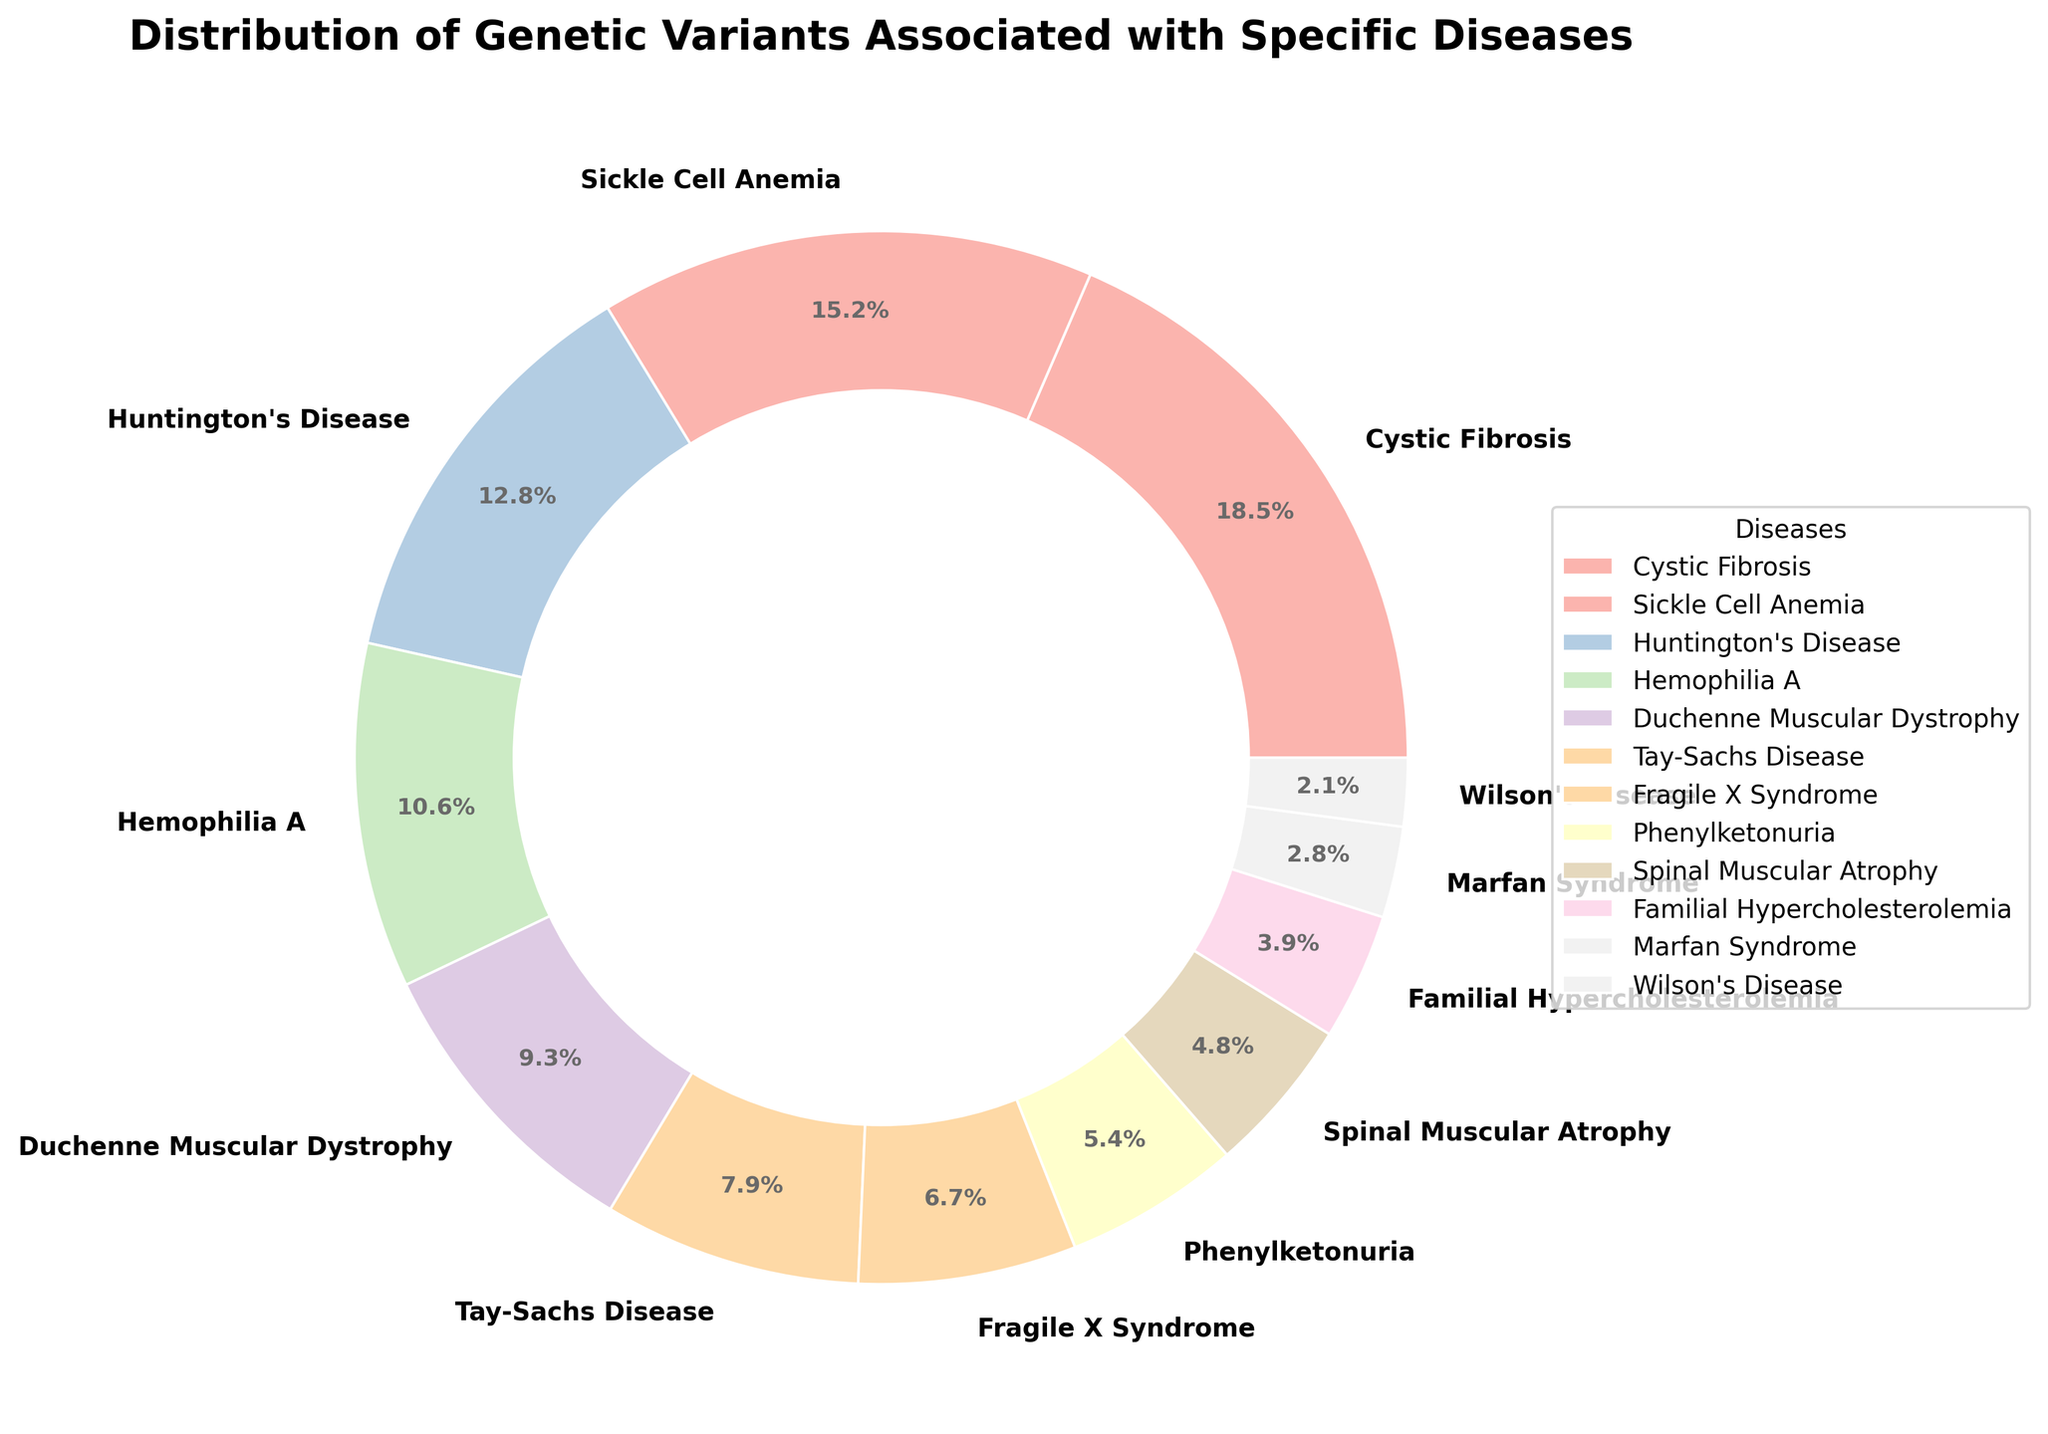What disease has the highest percentage of genetic variants? To determine the disease with the highest percentage of genetic variants, we look at the pie chart and identify the largest wedge. Cystic Fibrosis has the largest slice with 18.5%.
Answer: Cystic Fibrosis Which disease contributes the least to the distribution of genetic variants? We identify the smallest wedge in the pie chart to find the disease contributing the least. Wilson's Disease has the smallest slice with 2.1%.
Answer: Wilson's Disease What is the combined percentage of genetic variants for Huntington's Disease and Hemophilia A? Add the percentages for both diseases together: 12.8% (Huntington's Disease) + 10.6% (Hemophilia A) = 23.4%.
Answer: 23.4% Which diseases have a percentage of genetic variants less than 5%? By examining the pie chart, the diseases with less than 5% are Spinal Muscular Atrophy (4.8%), Familial Hypercholesterolemia (3.9%), Marfan Syndrome (2.8%), and Wilson's Disease (2.1%).
Answer: Spinal Muscular Atrophy, Familial Hypercholesterolemia, Marfan Syndrome, Wilson's Disease How much more prevalent is Cystic Fibrosis compared to Marfan Syndrome? Subtract the percentage of Marfan Syndrome from Cystic Fibrosis: 18.5% - 2.8% = 15.7%.
Answer: 15.7% What's the average percentage of genetic variants among Tay-Sachs Disease, Fragile X Syndrome, and Phenylketonuria? Add the percentages of the three diseases and divide by 3: (7.9% + 6.7% + 5.4%) / 3 = 6.67%.
Answer: 6.67% Compare the distribution percentages of Sickle Cell Anemia and Duchenne Muscular Dystrophy. Which has a higher distribution? By looking at the chart, Sickle Cell Anemia has 15.2%, while Duchenne Muscular Dystrophy has 9.3%. Therefore, Sickle Cell Anemia has a higher distribution.
Answer: Sickle Cell Anemia What is the visual representation color of Familial Hypercholesterolemia in the pie chart? The pie chart uses a range of colors. Familial Hypercholesterolemia is shown in a light pastel color among the varied palette. You can refer to the specific pastel shade for clarity.
Answer: Light pastel color 